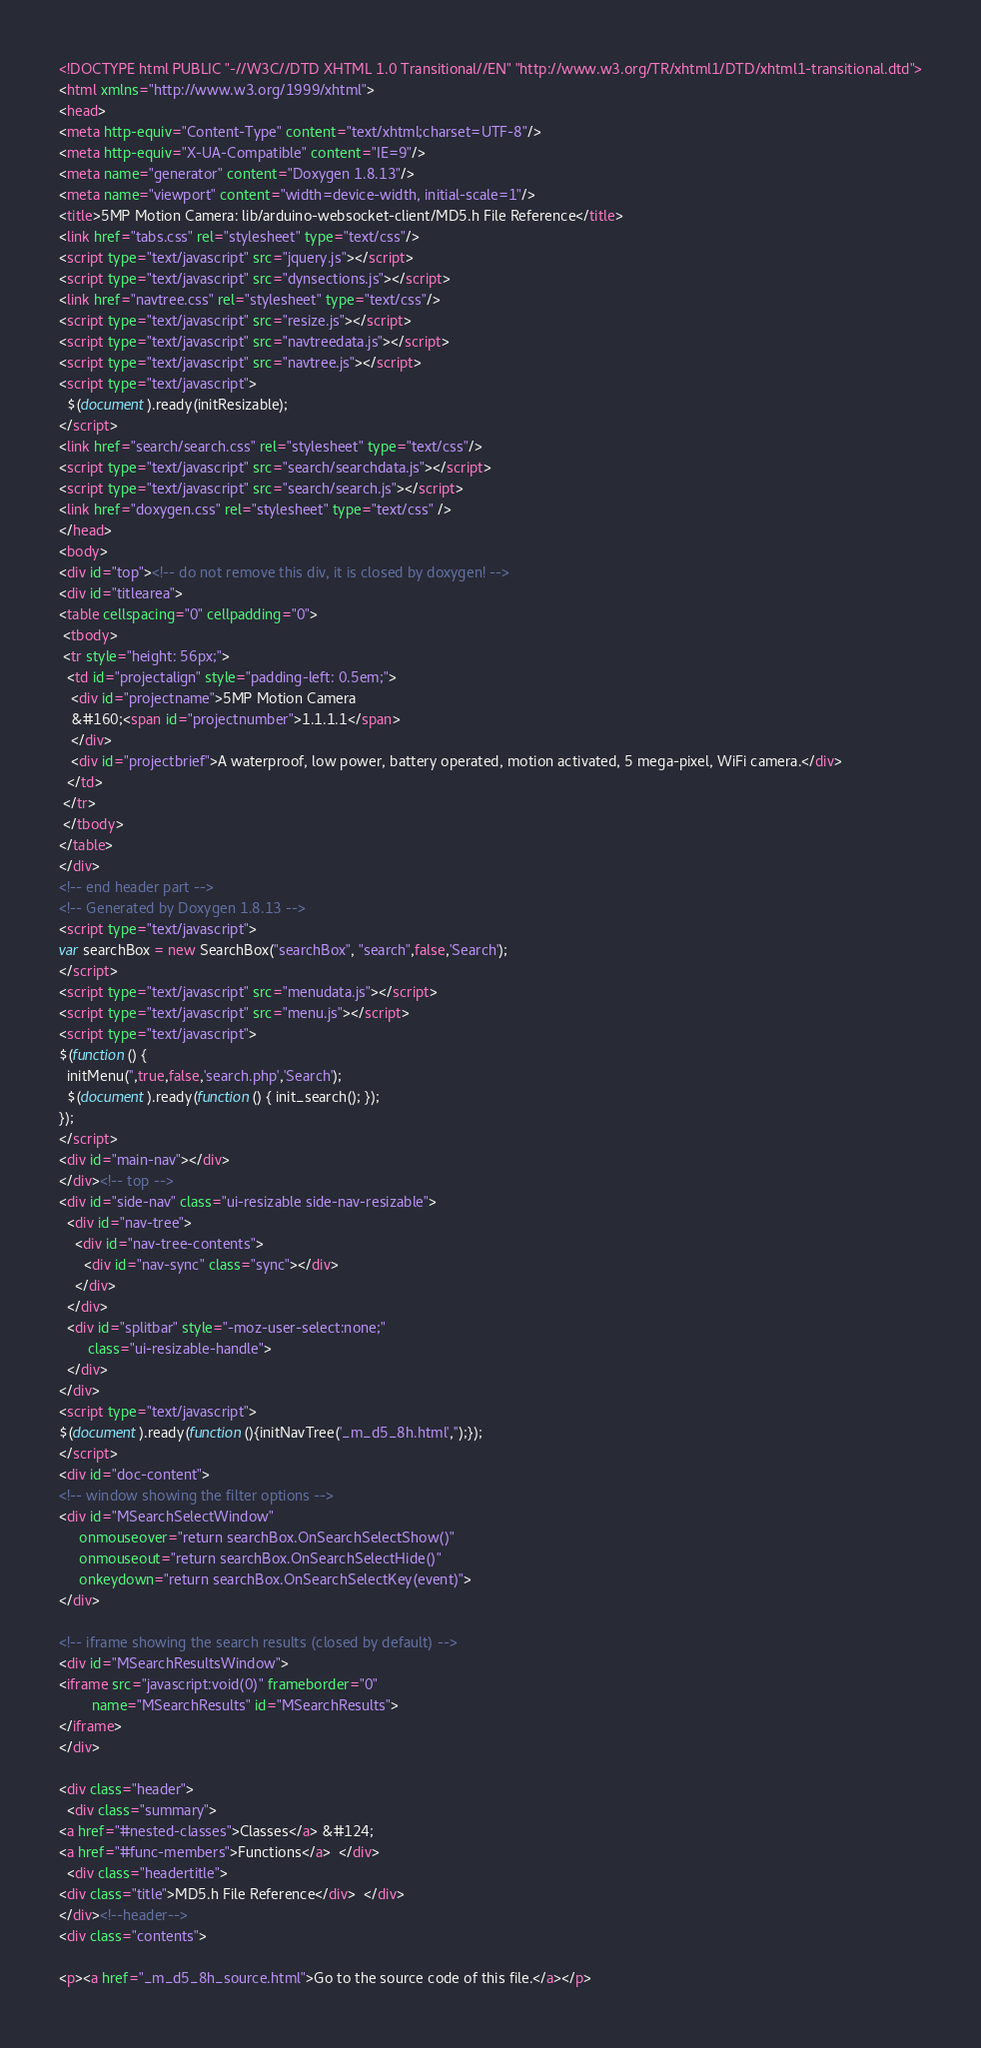<code> <loc_0><loc_0><loc_500><loc_500><_HTML_><!DOCTYPE html PUBLIC "-//W3C//DTD XHTML 1.0 Transitional//EN" "http://www.w3.org/TR/xhtml1/DTD/xhtml1-transitional.dtd">
<html xmlns="http://www.w3.org/1999/xhtml">
<head>
<meta http-equiv="Content-Type" content="text/xhtml;charset=UTF-8"/>
<meta http-equiv="X-UA-Compatible" content="IE=9"/>
<meta name="generator" content="Doxygen 1.8.13"/>
<meta name="viewport" content="width=device-width, initial-scale=1"/>
<title>5MP Motion Camera: lib/arduino-websocket-client/MD5.h File Reference</title>
<link href="tabs.css" rel="stylesheet" type="text/css"/>
<script type="text/javascript" src="jquery.js"></script>
<script type="text/javascript" src="dynsections.js"></script>
<link href="navtree.css" rel="stylesheet" type="text/css"/>
<script type="text/javascript" src="resize.js"></script>
<script type="text/javascript" src="navtreedata.js"></script>
<script type="text/javascript" src="navtree.js"></script>
<script type="text/javascript">
  $(document).ready(initResizable);
</script>
<link href="search/search.css" rel="stylesheet" type="text/css"/>
<script type="text/javascript" src="search/searchdata.js"></script>
<script type="text/javascript" src="search/search.js"></script>
<link href="doxygen.css" rel="stylesheet" type="text/css" />
</head>
<body>
<div id="top"><!-- do not remove this div, it is closed by doxygen! -->
<div id="titlearea">
<table cellspacing="0" cellpadding="0">
 <tbody>
 <tr style="height: 56px;">
  <td id="projectalign" style="padding-left: 0.5em;">
   <div id="projectname">5MP Motion Camera
   &#160;<span id="projectnumber">1.1.1.1</span>
   </div>
   <div id="projectbrief">A waterproof, low power, battery operated, motion activated, 5 mega-pixel, WiFi camera.</div>
  </td>
 </tr>
 </tbody>
</table>
</div>
<!-- end header part -->
<!-- Generated by Doxygen 1.8.13 -->
<script type="text/javascript">
var searchBox = new SearchBox("searchBox", "search",false,'Search');
</script>
<script type="text/javascript" src="menudata.js"></script>
<script type="text/javascript" src="menu.js"></script>
<script type="text/javascript">
$(function() {
  initMenu('',true,false,'search.php','Search');
  $(document).ready(function() { init_search(); });
});
</script>
<div id="main-nav"></div>
</div><!-- top -->
<div id="side-nav" class="ui-resizable side-nav-resizable">
  <div id="nav-tree">
    <div id="nav-tree-contents">
      <div id="nav-sync" class="sync"></div>
    </div>
  </div>
  <div id="splitbar" style="-moz-user-select:none;" 
       class="ui-resizable-handle">
  </div>
</div>
<script type="text/javascript">
$(document).ready(function(){initNavTree('_m_d5_8h.html','');});
</script>
<div id="doc-content">
<!-- window showing the filter options -->
<div id="MSearchSelectWindow"
     onmouseover="return searchBox.OnSearchSelectShow()"
     onmouseout="return searchBox.OnSearchSelectHide()"
     onkeydown="return searchBox.OnSearchSelectKey(event)">
</div>

<!-- iframe showing the search results (closed by default) -->
<div id="MSearchResultsWindow">
<iframe src="javascript:void(0)" frameborder="0" 
        name="MSearchResults" id="MSearchResults">
</iframe>
</div>

<div class="header">
  <div class="summary">
<a href="#nested-classes">Classes</a> &#124;
<a href="#func-members">Functions</a>  </div>
  <div class="headertitle">
<div class="title">MD5.h File Reference</div>  </div>
</div><!--header-->
<div class="contents">

<p><a href="_m_d5_8h_source.html">Go to the source code of this file.</a></p></code> 